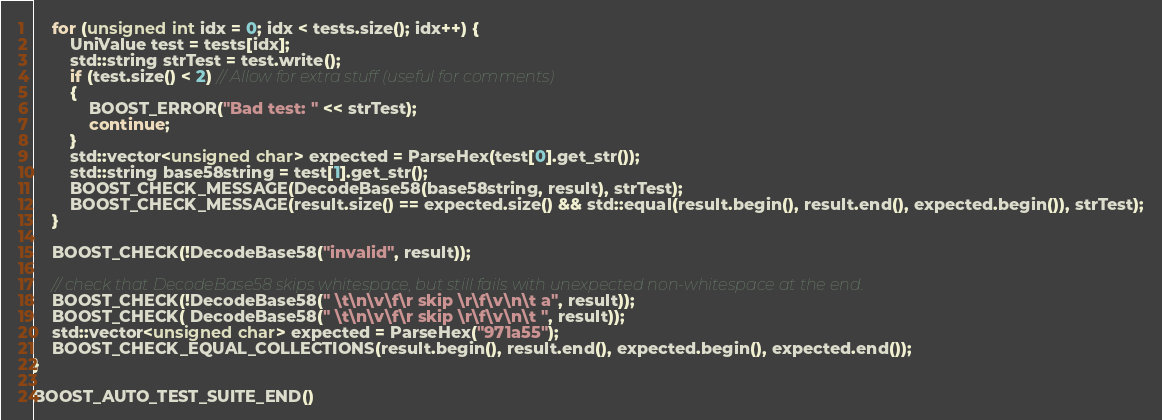<code> <loc_0><loc_0><loc_500><loc_500><_C++_>    for (unsigned int idx = 0; idx < tests.size(); idx++) {
        UniValue test = tests[idx];
        std::string strTest = test.write();
        if (test.size() < 2) // Allow for extra stuff (useful for comments)
        {
            BOOST_ERROR("Bad test: " << strTest);
            continue;
        }
        std::vector<unsigned char> expected = ParseHex(test[0].get_str());
        std::string base58string = test[1].get_str();
        BOOST_CHECK_MESSAGE(DecodeBase58(base58string, result), strTest);
        BOOST_CHECK_MESSAGE(result.size() == expected.size() && std::equal(result.begin(), result.end(), expected.begin()), strTest);
    }

    BOOST_CHECK(!DecodeBase58("invalid", result));

    // check that DecodeBase58 skips whitespace, but still fails with unexpected non-whitespace at the end.
    BOOST_CHECK(!DecodeBase58(" \t\n\v\f\r skip \r\f\v\n\t a", result));
    BOOST_CHECK( DecodeBase58(" \t\n\v\f\r skip \r\f\v\n\t ", result));
    std::vector<unsigned char> expected = ParseHex("971a55");
    BOOST_CHECK_EQUAL_COLLECTIONS(result.begin(), result.end(), expected.begin(), expected.end());
}

BOOST_AUTO_TEST_SUITE_END()
</code> 